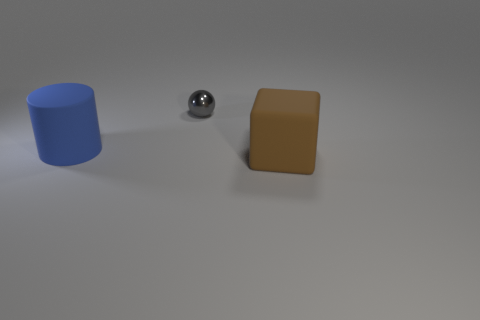Add 3 small cyan things. How many objects exist? 6 Subtract all blocks. How many objects are left? 2 Subtract 0 gray cylinders. How many objects are left? 3 Subtract all green shiny cylinders. Subtract all matte objects. How many objects are left? 1 Add 3 metallic things. How many metallic things are left? 4 Add 1 small yellow spheres. How many small yellow spheres exist? 1 